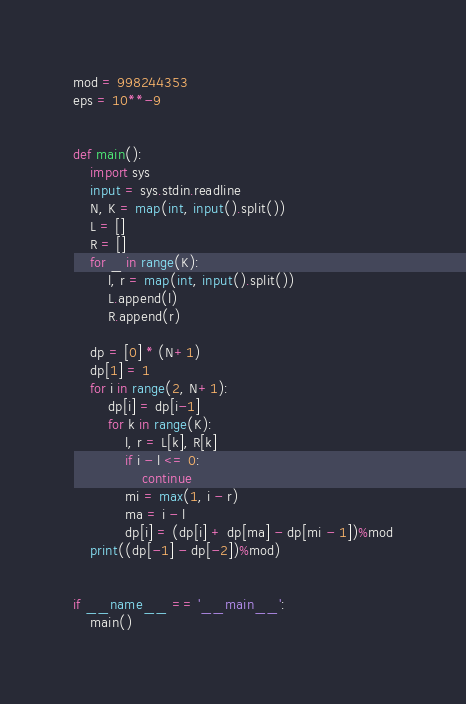Convert code to text. <code><loc_0><loc_0><loc_500><loc_500><_Python_>mod = 998244353
eps = 10**-9


def main():
    import sys
    input = sys.stdin.readline
    N, K = map(int, input().split())
    L = []
    R = []
    for _ in range(K):
        l, r = map(int, input().split())
        L.append(l)
        R.append(r)

    dp = [0] * (N+1)
    dp[1] = 1
    for i in range(2, N+1):
        dp[i] = dp[i-1]
        for k in range(K):
            l, r = L[k], R[k]
            if i - l <= 0:
                continue
            mi = max(1, i - r)
            ma = i - l
            dp[i] = (dp[i] + dp[ma] - dp[mi - 1])%mod
    print((dp[-1] - dp[-2])%mod)


if __name__ == '__main__':
    main()
</code> 